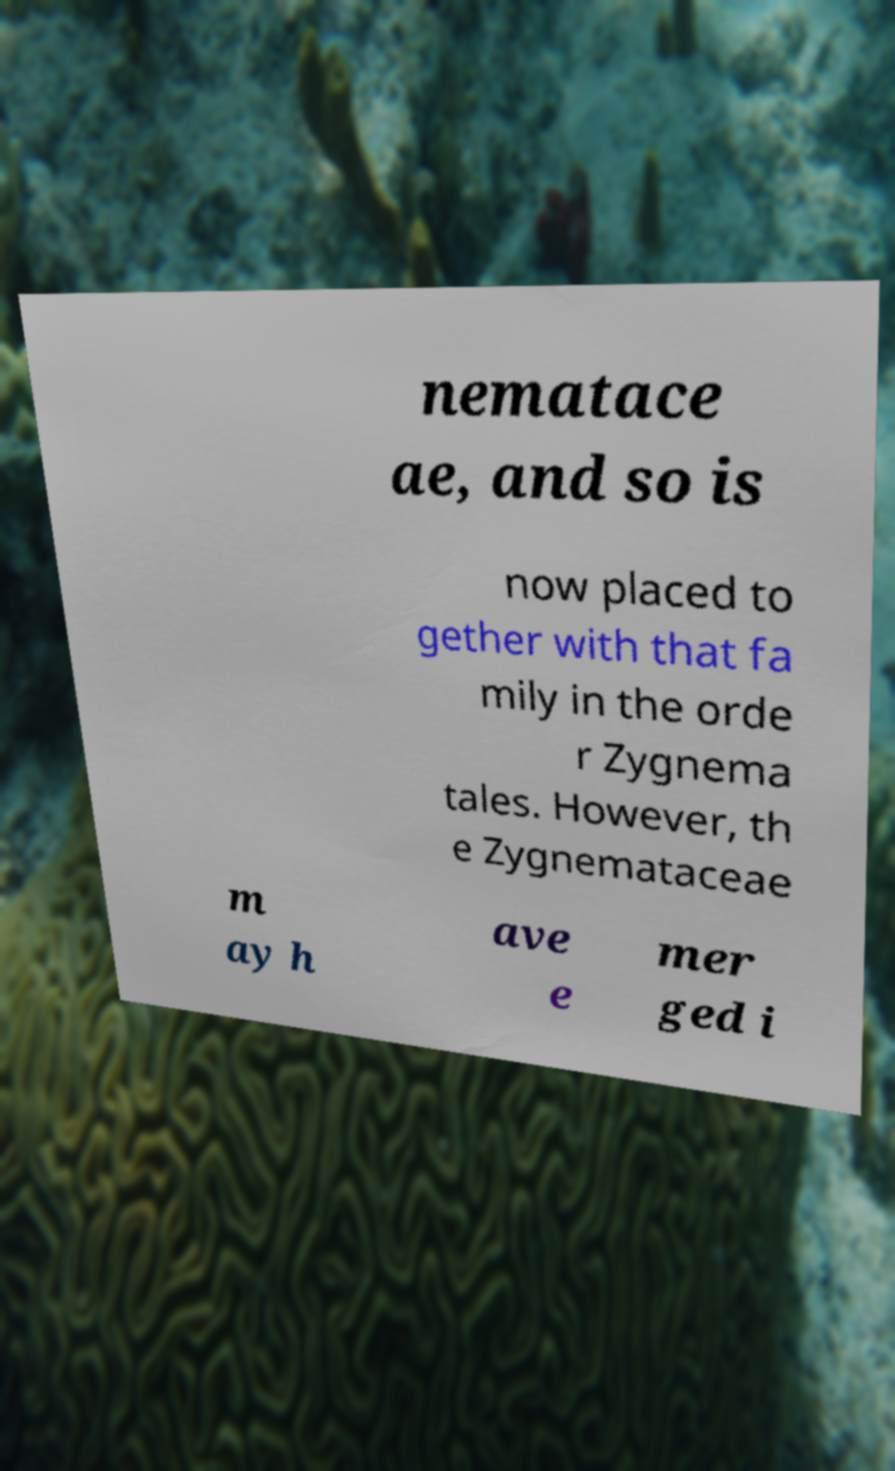Please identify and transcribe the text found in this image. nematace ae, and so is now placed to gether with that fa mily in the orde r Zygnema tales. However, th e Zygnemataceae m ay h ave e mer ged i 